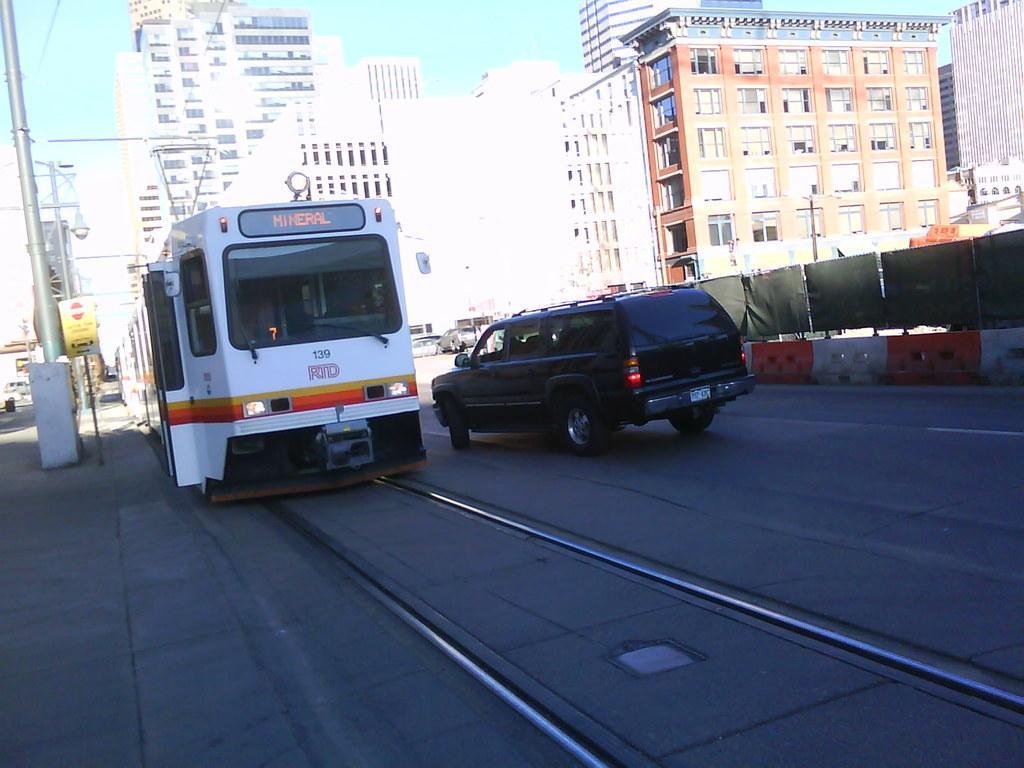Describe this image in one or two sentences. In the picture we can see a tram and a car are moving on the road. Here we can see the barriers, poles, boards, light poles, buildings and the sky in the background. 